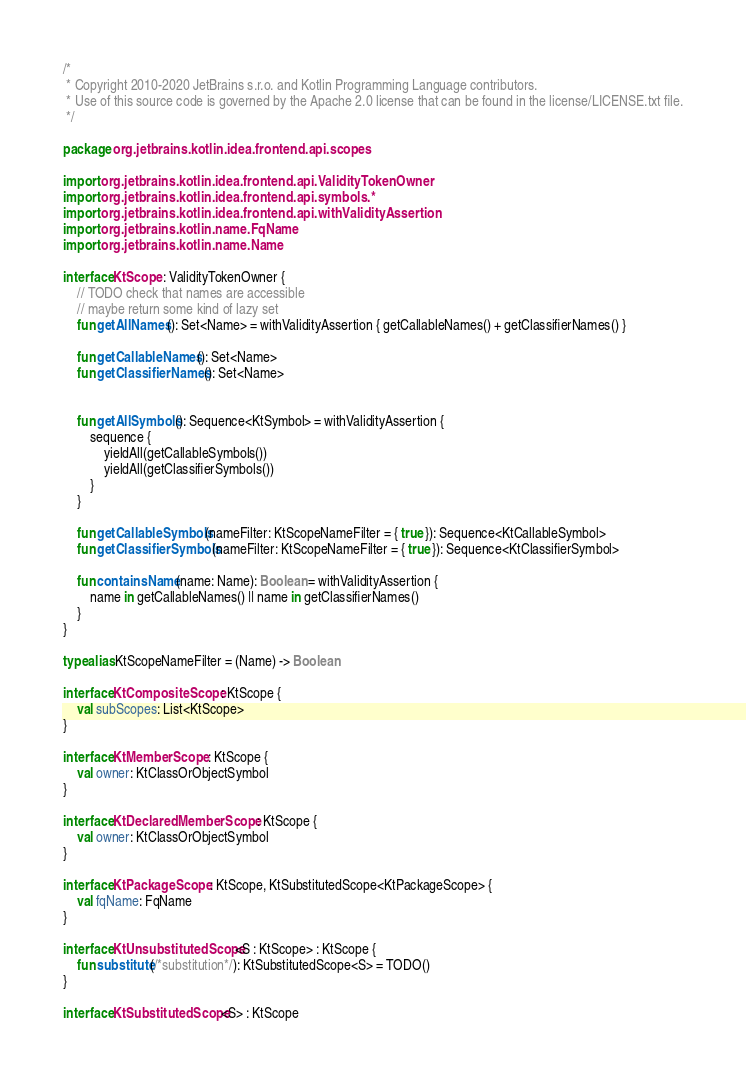<code> <loc_0><loc_0><loc_500><loc_500><_Kotlin_>/*
 * Copyright 2010-2020 JetBrains s.r.o. and Kotlin Programming Language contributors.
 * Use of this source code is governed by the Apache 2.0 license that can be found in the license/LICENSE.txt file.
 */

package org.jetbrains.kotlin.idea.frontend.api.scopes

import org.jetbrains.kotlin.idea.frontend.api.ValidityTokenOwner
import org.jetbrains.kotlin.idea.frontend.api.symbols.*
import org.jetbrains.kotlin.idea.frontend.api.withValidityAssertion
import org.jetbrains.kotlin.name.FqName
import org.jetbrains.kotlin.name.Name

interface KtScope : ValidityTokenOwner {
    // TODO check that names are accessible
    // maybe return some kind of lazy set
    fun getAllNames(): Set<Name> = withValidityAssertion { getCallableNames() + getClassifierNames() }

    fun getCallableNames(): Set<Name>
    fun getClassifierNames(): Set<Name>


    fun getAllSymbols(): Sequence<KtSymbol> = withValidityAssertion {
        sequence {
            yieldAll(getCallableSymbols())
            yieldAll(getClassifierSymbols())
        }
    }

    fun getCallableSymbols(nameFilter: KtScopeNameFilter = { true }): Sequence<KtCallableSymbol>
    fun getClassifierSymbols(nameFilter: KtScopeNameFilter = { true }): Sequence<KtClassifierSymbol>

    fun containsName(name: Name): Boolean = withValidityAssertion {
        name in getCallableNames() || name in getClassifierNames()
    }
}

typealias KtScopeNameFilter = (Name) -> Boolean

interface KtCompositeScope : KtScope {
    val subScopes: List<KtScope>
}

interface KtMemberScope : KtScope {
    val owner: KtClassOrObjectSymbol
}

interface KtDeclaredMemberScope : KtScope {
    val owner: KtClassOrObjectSymbol
}

interface KtPackageScope : KtScope, KtSubstitutedScope<KtPackageScope> {
    val fqName: FqName
}

interface KtUnsubstitutedScope<S : KtScope> : KtScope {
    fun substitute(/*substitution*/): KtSubstitutedScope<S> = TODO()
}

interface KtSubstitutedScope<S> : KtScope</code> 